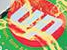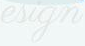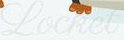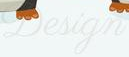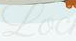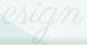What words can you see in these images in sequence, separated by a semicolon? up; esign; Locket; Design; Loc; esign 